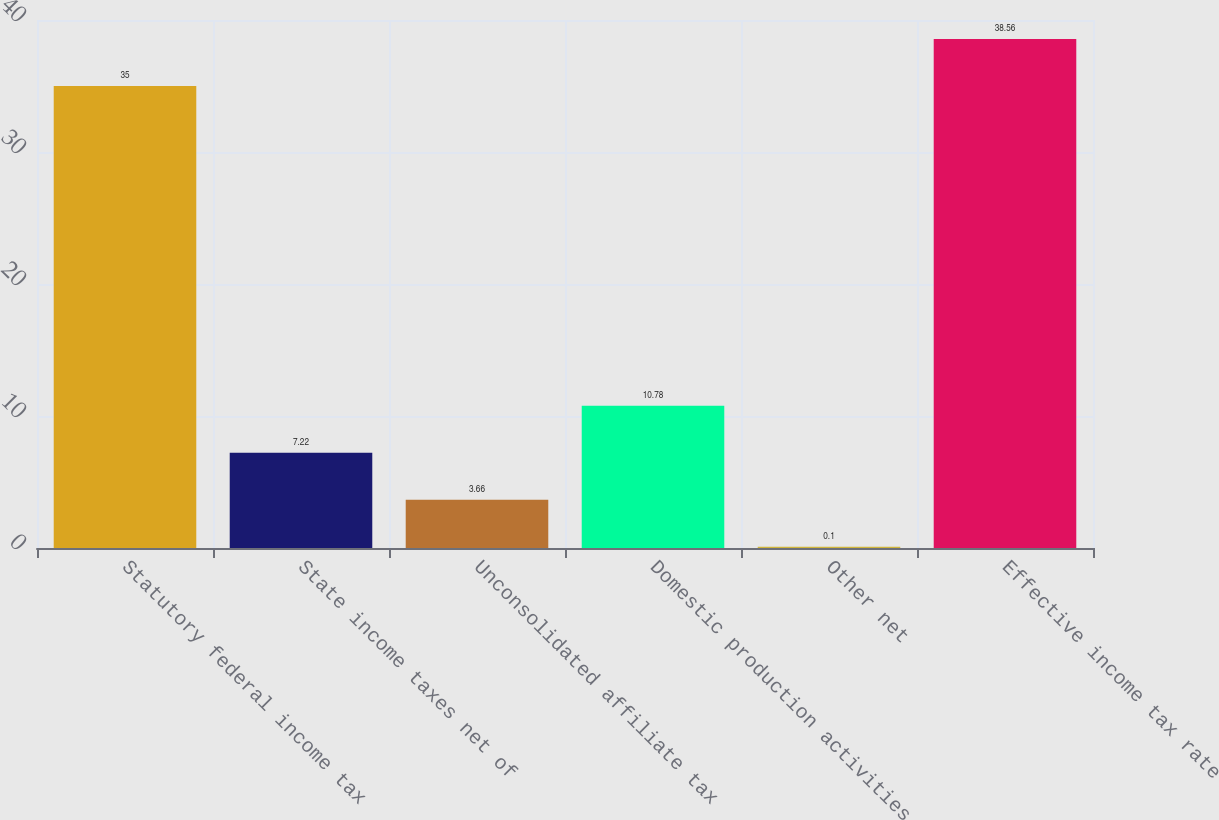Convert chart. <chart><loc_0><loc_0><loc_500><loc_500><bar_chart><fcel>Statutory federal income tax<fcel>State income taxes net of<fcel>Unconsolidated affiliate tax<fcel>Domestic production activities<fcel>Other net<fcel>Effective income tax rate<nl><fcel>35<fcel>7.22<fcel>3.66<fcel>10.78<fcel>0.1<fcel>38.56<nl></chart> 